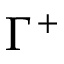Convert formula to latex. <formula><loc_0><loc_0><loc_500><loc_500>\Gamma ^ { + }</formula> 